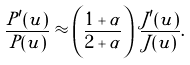<formula> <loc_0><loc_0><loc_500><loc_500>\frac { P ^ { \prime } ( u ) } { P ( u ) } \approx \left ( \frac { 1 + \alpha } { 2 + \alpha } \right ) \, \frac { J ^ { \prime } ( u ) } { J ( u ) } .</formula> 